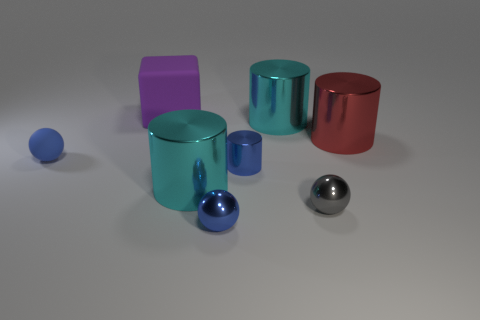Subtract all large cylinders. How many cylinders are left? 1 Subtract all blue cylinders. How many cylinders are left? 3 Add 1 small blue objects. How many objects exist? 9 Subtract all brown cylinders. Subtract all blue balls. How many cylinders are left? 4 Subtract all blocks. How many objects are left? 7 Add 7 purple cubes. How many purple cubes exist? 8 Subtract 1 red cylinders. How many objects are left? 7 Subtract all tiny blue spheres. Subtract all big shiny objects. How many objects are left? 3 Add 6 metallic cylinders. How many metallic cylinders are left? 10 